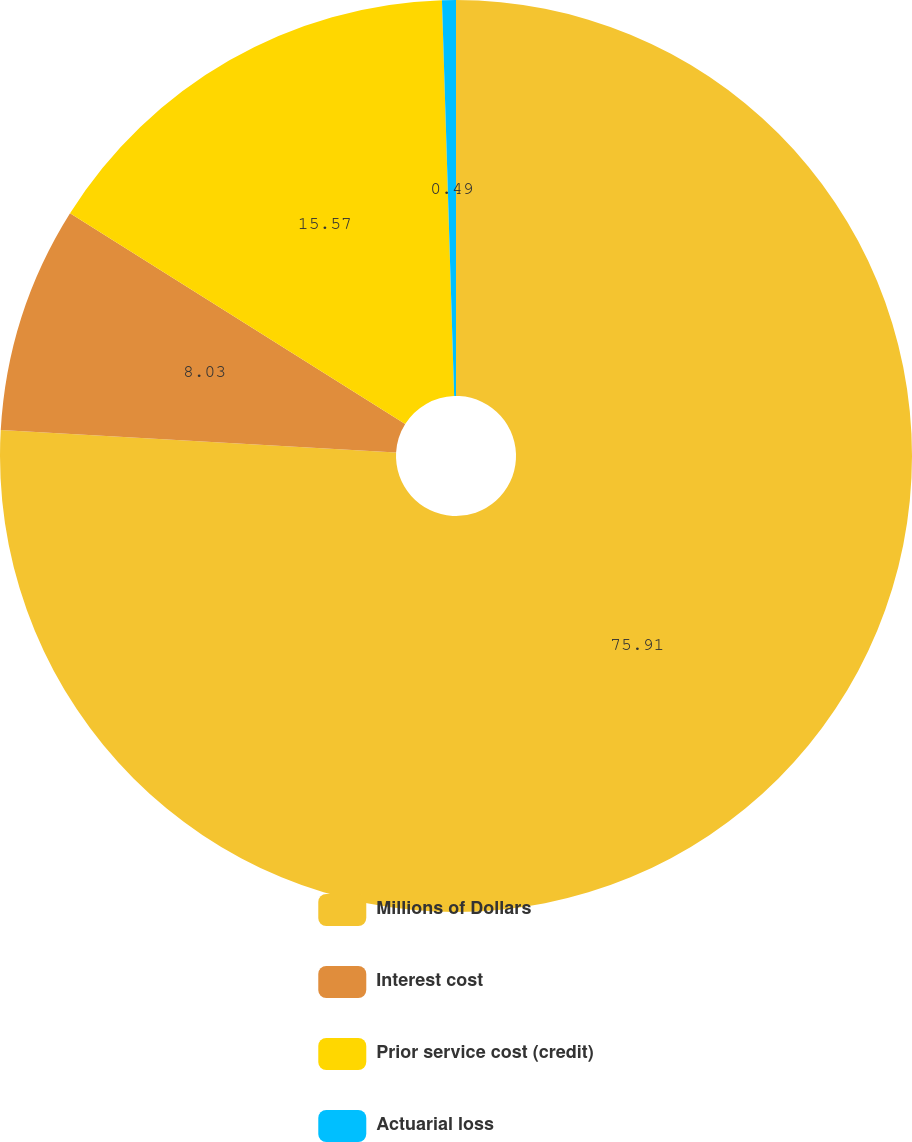<chart> <loc_0><loc_0><loc_500><loc_500><pie_chart><fcel>Millions of Dollars<fcel>Interest cost<fcel>Prior service cost (credit)<fcel>Actuarial loss<nl><fcel>75.9%<fcel>8.03%<fcel>15.57%<fcel>0.49%<nl></chart> 